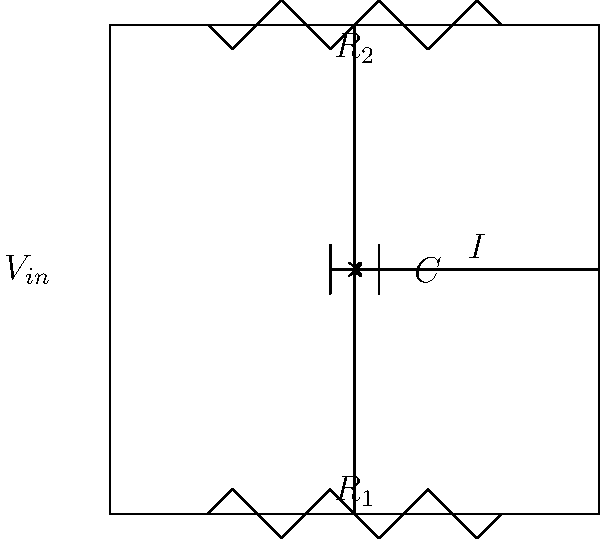In the given RC circuit, if the input voltage $V_{in}$ undergoes a sudden change, how would you describe the current $I$ through the circuit immediately after the change and after a long time has passed? Consider the linguistic concept of "continuum" in your analysis. To analyze this circuit, we'll follow these steps, drawing parallels to linguistic concepts:

1) Initial state (immediately after change):
   Just as a sudden change in language might cause immediate confusion, the capacitor acts as a short circuit immediately after a voltage change. This is because the voltage across a capacitor cannot change instantaneously.

   The current $I$ will be at its maximum, determined by:
   
   $$I_{max} = \frac{V_{in}}{R_1 + R_2}$$

2) Transient state:
   Like how a language adapts over time, the circuit undergoes a transient state. The capacitor begins to charge, and its voltage increases. This causes the current to decrease exponentially:

   $$I(t) = I_{max} \cdot e^{-t/\tau}$$

   where $\tau = (R_1 + R_2)C$ is the time constant.

3) Steady state (after a long time):
   Eventually, like a language reaching a new equilibrium, the circuit reaches steady state. The capacitor becomes fully charged and acts as an open circuit. The current approaches zero:

   $$I_{steady} \approx 0$$

This behavior forms a continuum from maximum current to zero current, much like how language changes form a continuum from one state to another.
Answer: Immediately after: maximum current ($I_{max} = \frac{V_{in}}{R_1 + R_2}$). After long time: approximately zero current. 